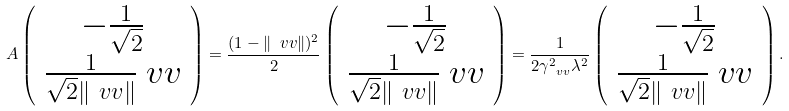Convert formula to latex. <formula><loc_0><loc_0><loc_500><loc_500>A \left ( \begin{array} { c } - \frac { 1 } { \sqrt { 2 } } \\ \frac { 1 } { \sqrt { 2 } \| \ v v \| } \ v v \\ \end{array} \right ) = \frac { ( 1 - \| \ v v \| ) ^ { 2 } } { 2 } \left ( \begin{array} { c } - \frac { 1 } { \sqrt { 2 } } \\ \frac { 1 } { \sqrt { 2 } \| \ v v \| } \ v v \\ \end{array} \right ) = \frac { 1 } { 2 \gamma _ { \ v v } ^ { 2 } \lambda ^ { 2 } } \left ( \begin{array} { c } - \frac { 1 } { \sqrt { 2 } } \\ \frac { 1 } { \sqrt { 2 } \| \ v v \| } \ v v \\ \end{array} \right ) .</formula> 